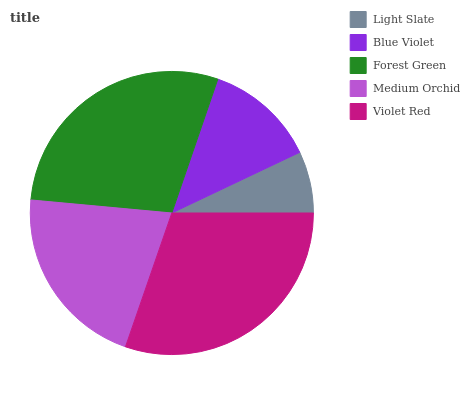Is Light Slate the minimum?
Answer yes or no. Yes. Is Violet Red the maximum?
Answer yes or no. Yes. Is Blue Violet the minimum?
Answer yes or no. No. Is Blue Violet the maximum?
Answer yes or no. No. Is Blue Violet greater than Light Slate?
Answer yes or no. Yes. Is Light Slate less than Blue Violet?
Answer yes or no. Yes. Is Light Slate greater than Blue Violet?
Answer yes or no. No. Is Blue Violet less than Light Slate?
Answer yes or no. No. Is Medium Orchid the high median?
Answer yes or no. Yes. Is Medium Orchid the low median?
Answer yes or no. Yes. Is Violet Red the high median?
Answer yes or no. No. Is Forest Green the low median?
Answer yes or no. No. 